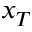Convert formula to latex. <formula><loc_0><loc_0><loc_500><loc_500>x _ { T }</formula> 